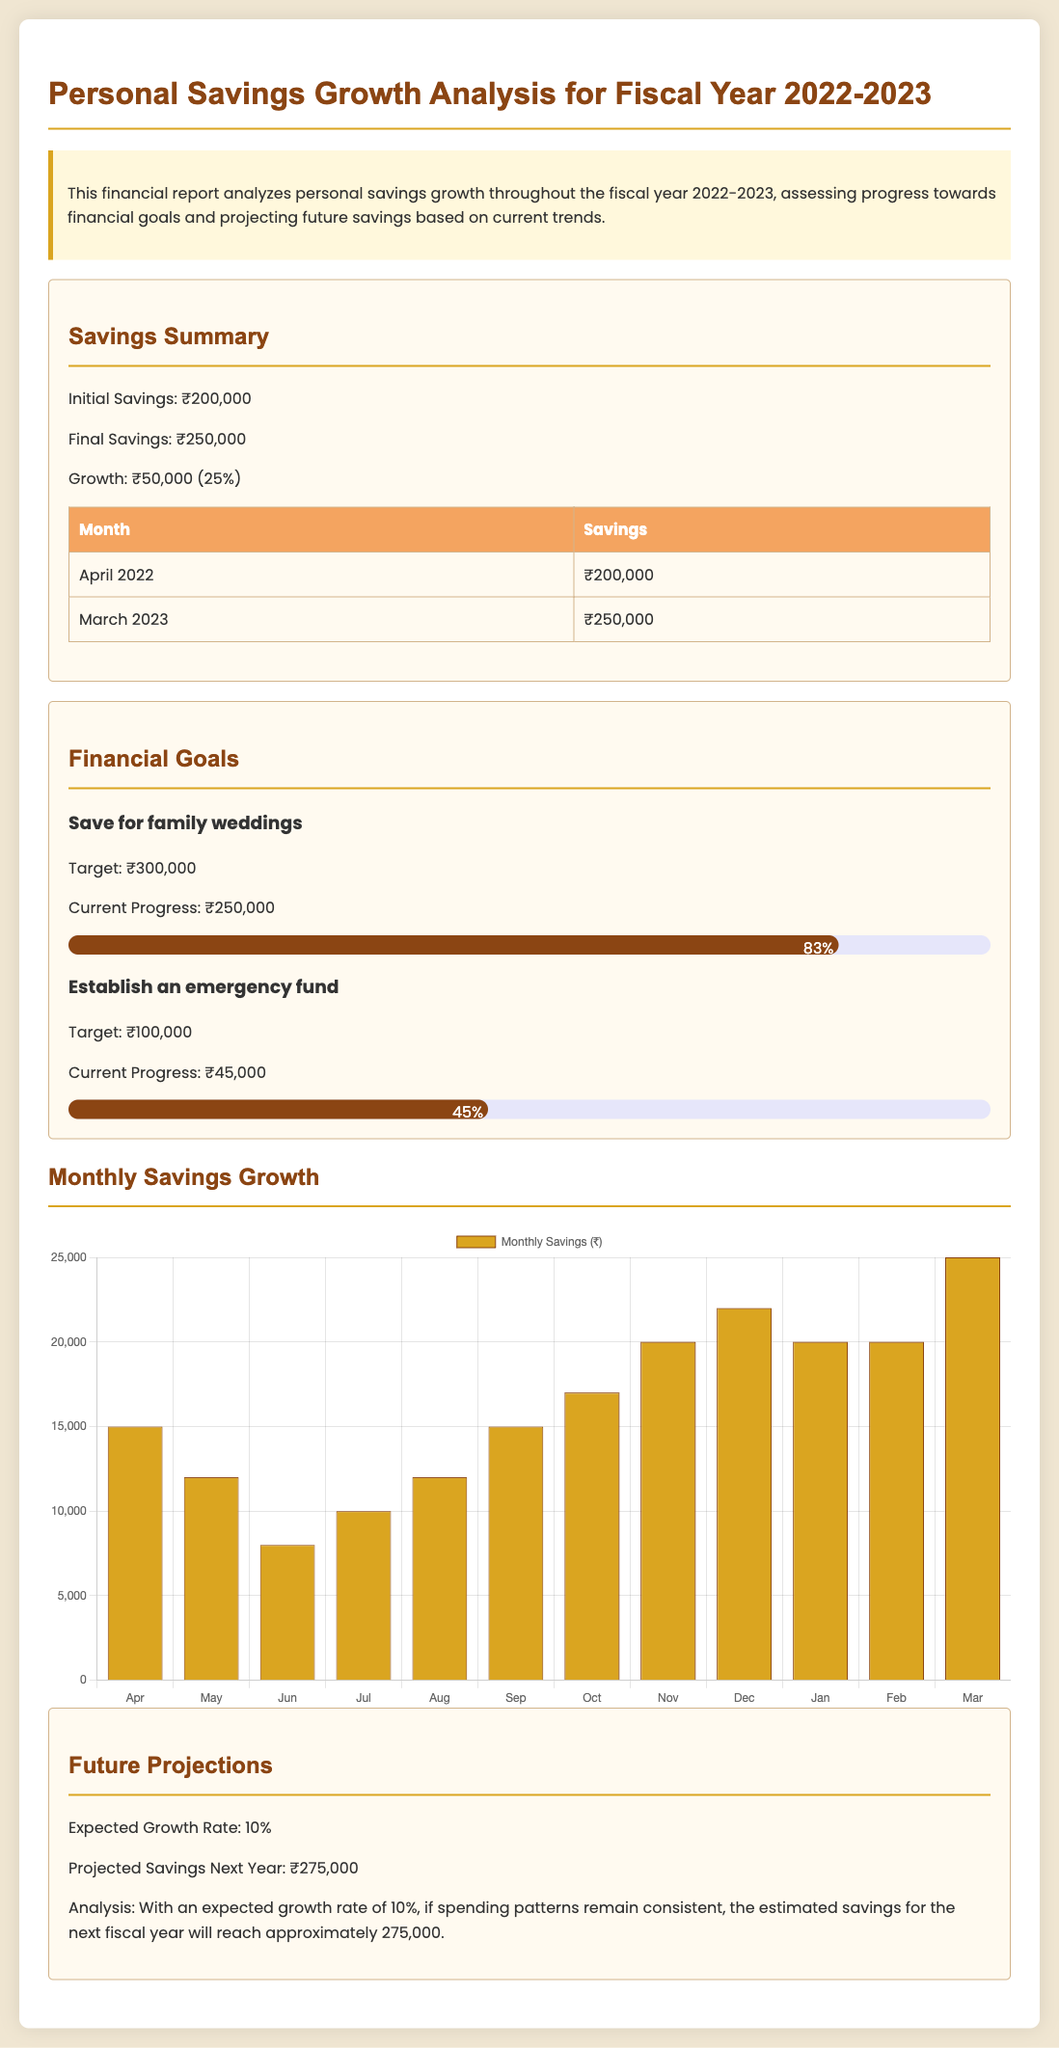What was the initial savings amount? The initial savings amount listed in the document is ₹200,000.
Answer: ₹200,000 What is the final savings amount at the end of the fiscal year? The final savings amount mentioned in the conclusion of the report is ₹250,000.
Answer: ₹250,000 What is the total growth in savings? The total growth in savings, as indicated in the summary, is ₹50,000.
Answer: ₹50,000 What is the target amount for saving for family weddings? The target amount specified for family weddings is ₹300,000.
Answer: ₹300,000 What percentage of the emergency fund goal has been achieved? The progress towards the emergency fund goal is 45%, as shown in the report.
Answer: 45% What is the expected growth rate for the next fiscal year? The expected growth rate, according to the future projections section, is 10%.
Answer: 10% How much is projected to be saved next year? The projected savings for the next year are noted as ₹275,000 in the document.
Answer: ₹275,000 What type of chart is displayed for monthly savings growth? The type of chart presented in the report for monthly savings growth is a bar chart.
Answer: bar What is the highest monthly savings recorded? The highest monthly savings recorded in the chart is ₹25,000 in March.
Answer: ₹25,000 